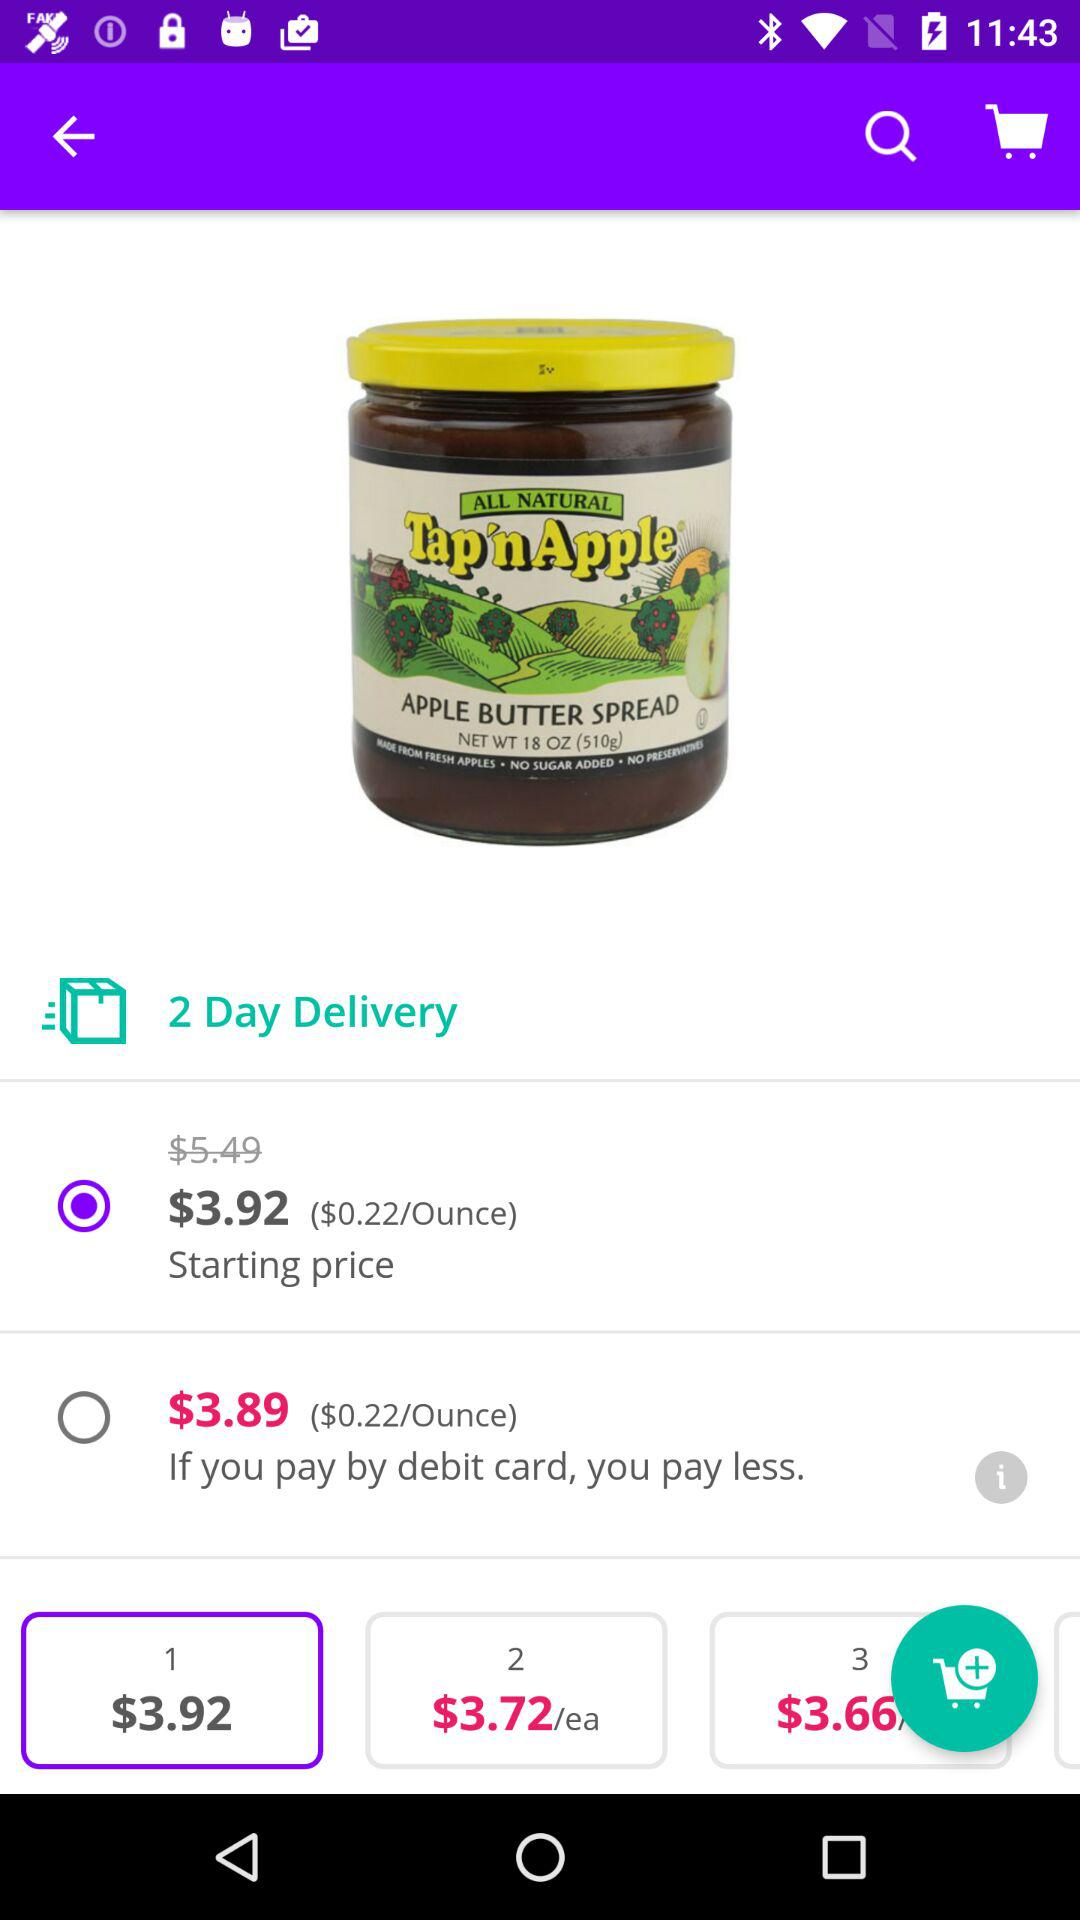What is the delivery time? The delivery time is 2 days. 